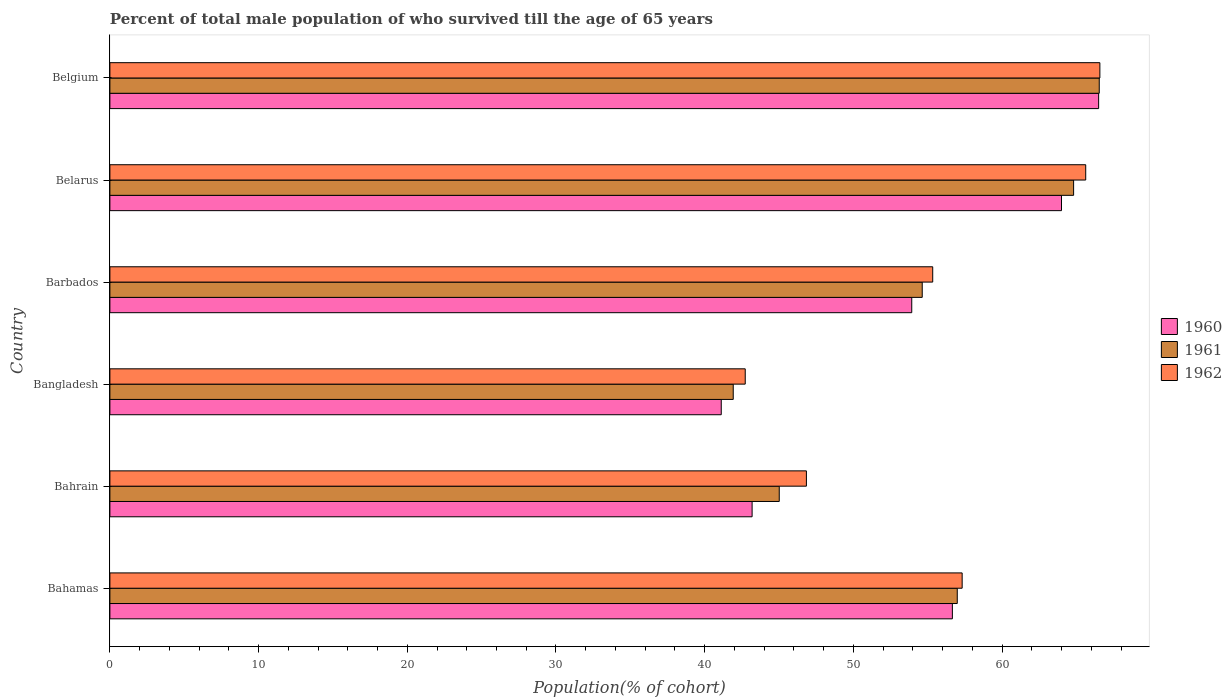How many groups of bars are there?
Your response must be concise. 6. Are the number of bars on each tick of the Y-axis equal?
Give a very brief answer. Yes. How many bars are there on the 1st tick from the top?
Offer a terse response. 3. How many bars are there on the 3rd tick from the bottom?
Your answer should be compact. 3. What is the label of the 5th group of bars from the top?
Offer a terse response. Bahrain. In how many cases, is the number of bars for a given country not equal to the number of legend labels?
Give a very brief answer. 0. What is the percentage of total male population who survived till the age of 65 years in 1960 in Belarus?
Your answer should be very brief. 64. Across all countries, what is the maximum percentage of total male population who survived till the age of 65 years in 1960?
Offer a very short reply. 66.5. Across all countries, what is the minimum percentage of total male population who survived till the age of 65 years in 1960?
Provide a succinct answer. 41.12. In which country was the percentage of total male population who survived till the age of 65 years in 1962 minimum?
Keep it short and to the point. Bangladesh. What is the total percentage of total male population who survived till the age of 65 years in 1962 in the graph?
Offer a very short reply. 334.43. What is the difference between the percentage of total male population who survived till the age of 65 years in 1960 in Barbados and that in Belarus?
Your response must be concise. -10.07. What is the difference between the percentage of total male population who survived till the age of 65 years in 1960 in Belarus and the percentage of total male population who survived till the age of 65 years in 1962 in Belgium?
Your response must be concise. -2.58. What is the average percentage of total male population who survived till the age of 65 years in 1960 per country?
Your answer should be very brief. 54.23. What is the difference between the percentage of total male population who survived till the age of 65 years in 1961 and percentage of total male population who survived till the age of 65 years in 1960 in Belgium?
Keep it short and to the point. 0.04. In how many countries, is the percentage of total male population who survived till the age of 65 years in 1960 greater than 50 %?
Offer a very short reply. 4. What is the ratio of the percentage of total male population who survived till the age of 65 years in 1960 in Bahrain to that in Bangladesh?
Provide a succinct answer. 1.05. What is the difference between the highest and the second highest percentage of total male population who survived till the age of 65 years in 1960?
Ensure brevity in your answer.  2.5. What is the difference between the highest and the lowest percentage of total male population who survived till the age of 65 years in 1960?
Provide a short and direct response. 25.38. In how many countries, is the percentage of total male population who survived till the age of 65 years in 1960 greater than the average percentage of total male population who survived till the age of 65 years in 1960 taken over all countries?
Provide a short and direct response. 3. Is the sum of the percentage of total male population who survived till the age of 65 years in 1962 in Bangladesh and Belarus greater than the maximum percentage of total male population who survived till the age of 65 years in 1960 across all countries?
Your answer should be very brief. Yes. What does the 3rd bar from the top in Bangladesh represents?
Keep it short and to the point. 1960. Is it the case that in every country, the sum of the percentage of total male population who survived till the age of 65 years in 1961 and percentage of total male population who survived till the age of 65 years in 1962 is greater than the percentage of total male population who survived till the age of 65 years in 1960?
Offer a terse response. Yes. Are all the bars in the graph horizontal?
Ensure brevity in your answer.  Yes. What is the difference between two consecutive major ticks on the X-axis?
Offer a terse response. 10. Are the values on the major ticks of X-axis written in scientific E-notation?
Ensure brevity in your answer.  No. Where does the legend appear in the graph?
Provide a short and direct response. Center right. What is the title of the graph?
Provide a short and direct response. Percent of total male population of who survived till the age of 65 years. What is the label or title of the X-axis?
Offer a terse response. Population(% of cohort). What is the label or title of the Y-axis?
Your answer should be very brief. Country. What is the Population(% of cohort) of 1960 in Bahamas?
Offer a very short reply. 56.66. What is the Population(% of cohort) in 1961 in Bahamas?
Offer a terse response. 56.99. What is the Population(% of cohort) in 1962 in Bahamas?
Ensure brevity in your answer.  57.32. What is the Population(% of cohort) of 1960 in Bahrain?
Ensure brevity in your answer.  43.19. What is the Population(% of cohort) in 1961 in Bahrain?
Your answer should be compact. 45.02. What is the Population(% of cohort) in 1962 in Bahrain?
Provide a succinct answer. 46.84. What is the Population(% of cohort) of 1960 in Bangladesh?
Your response must be concise. 41.12. What is the Population(% of cohort) of 1961 in Bangladesh?
Provide a short and direct response. 41.92. What is the Population(% of cohort) in 1962 in Bangladesh?
Provide a short and direct response. 42.73. What is the Population(% of cohort) of 1960 in Barbados?
Your answer should be very brief. 53.93. What is the Population(% of cohort) of 1961 in Barbados?
Offer a very short reply. 54.63. What is the Population(% of cohort) in 1962 in Barbados?
Offer a terse response. 55.34. What is the Population(% of cohort) in 1960 in Belarus?
Offer a terse response. 64. What is the Population(% of cohort) of 1961 in Belarus?
Make the answer very short. 64.81. What is the Population(% of cohort) in 1962 in Belarus?
Keep it short and to the point. 65.63. What is the Population(% of cohort) of 1960 in Belgium?
Your response must be concise. 66.5. What is the Population(% of cohort) in 1961 in Belgium?
Ensure brevity in your answer.  66.54. What is the Population(% of cohort) of 1962 in Belgium?
Ensure brevity in your answer.  66.58. Across all countries, what is the maximum Population(% of cohort) in 1960?
Your answer should be compact. 66.5. Across all countries, what is the maximum Population(% of cohort) of 1961?
Offer a terse response. 66.54. Across all countries, what is the maximum Population(% of cohort) of 1962?
Offer a terse response. 66.58. Across all countries, what is the minimum Population(% of cohort) of 1960?
Your answer should be compact. 41.12. Across all countries, what is the minimum Population(% of cohort) in 1961?
Your answer should be very brief. 41.92. Across all countries, what is the minimum Population(% of cohort) in 1962?
Provide a succinct answer. 42.73. What is the total Population(% of cohort) in 1960 in the graph?
Your answer should be compact. 325.39. What is the total Population(% of cohort) of 1961 in the graph?
Provide a short and direct response. 329.91. What is the total Population(% of cohort) of 1962 in the graph?
Your answer should be very brief. 334.43. What is the difference between the Population(% of cohort) of 1960 in Bahamas and that in Bahrain?
Ensure brevity in your answer.  13.47. What is the difference between the Population(% of cohort) of 1961 in Bahamas and that in Bahrain?
Ensure brevity in your answer.  11.97. What is the difference between the Population(% of cohort) in 1962 in Bahamas and that in Bahrain?
Ensure brevity in your answer.  10.47. What is the difference between the Population(% of cohort) of 1960 in Bahamas and that in Bangladesh?
Your answer should be compact. 15.54. What is the difference between the Population(% of cohort) of 1961 in Bahamas and that in Bangladesh?
Your response must be concise. 15.07. What is the difference between the Population(% of cohort) in 1962 in Bahamas and that in Bangladesh?
Give a very brief answer. 14.59. What is the difference between the Population(% of cohort) of 1960 in Bahamas and that in Barbados?
Offer a terse response. 2.73. What is the difference between the Population(% of cohort) in 1961 in Bahamas and that in Barbados?
Ensure brevity in your answer.  2.36. What is the difference between the Population(% of cohort) in 1962 in Bahamas and that in Barbados?
Make the answer very short. 1.98. What is the difference between the Population(% of cohort) of 1960 in Bahamas and that in Belarus?
Your answer should be compact. -7.34. What is the difference between the Population(% of cohort) of 1961 in Bahamas and that in Belarus?
Your response must be concise. -7.82. What is the difference between the Population(% of cohort) in 1962 in Bahamas and that in Belarus?
Your response must be concise. -8.31. What is the difference between the Population(% of cohort) of 1960 in Bahamas and that in Belgium?
Provide a succinct answer. -9.84. What is the difference between the Population(% of cohort) of 1961 in Bahamas and that in Belgium?
Provide a succinct answer. -9.55. What is the difference between the Population(% of cohort) in 1962 in Bahamas and that in Belgium?
Your response must be concise. -9.26. What is the difference between the Population(% of cohort) in 1960 in Bahrain and that in Bangladesh?
Offer a terse response. 2.08. What is the difference between the Population(% of cohort) in 1961 in Bahrain and that in Bangladesh?
Provide a succinct answer. 3.09. What is the difference between the Population(% of cohort) of 1962 in Bahrain and that in Bangladesh?
Provide a succinct answer. 4.11. What is the difference between the Population(% of cohort) in 1960 in Bahrain and that in Barbados?
Make the answer very short. -10.74. What is the difference between the Population(% of cohort) of 1961 in Bahrain and that in Barbados?
Your answer should be very brief. -9.62. What is the difference between the Population(% of cohort) in 1962 in Bahrain and that in Barbados?
Offer a very short reply. -8.5. What is the difference between the Population(% of cohort) of 1960 in Bahrain and that in Belarus?
Your response must be concise. -20.81. What is the difference between the Population(% of cohort) in 1961 in Bahrain and that in Belarus?
Your answer should be very brief. -19.8. What is the difference between the Population(% of cohort) of 1962 in Bahrain and that in Belarus?
Offer a terse response. -18.78. What is the difference between the Population(% of cohort) in 1960 in Bahrain and that in Belgium?
Give a very brief answer. -23.31. What is the difference between the Population(% of cohort) of 1961 in Bahrain and that in Belgium?
Offer a terse response. -21.52. What is the difference between the Population(% of cohort) in 1962 in Bahrain and that in Belgium?
Offer a very short reply. -19.74. What is the difference between the Population(% of cohort) in 1960 in Bangladesh and that in Barbados?
Offer a very short reply. -12.81. What is the difference between the Population(% of cohort) in 1961 in Bangladesh and that in Barbados?
Provide a succinct answer. -12.71. What is the difference between the Population(% of cohort) in 1962 in Bangladesh and that in Barbados?
Offer a very short reply. -12.61. What is the difference between the Population(% of cohort) in 1960 in Bangladesh and that in Belarus?
Your answer should be compact. -22.88. What is the difference between the Population(% of cohort) of 1961 in Bangladesh and that in Belarus?
Your answer should be compact. -22.89. What is the difference between the Population(% of cohort) in 1962 in Bangladesh and that in Belarus?
Make the answer very short. -22.9. What is the difference between the Population(% of cohort) of 1960 in Bangladesh and that in Belgium?
Give a very brief answer. -25.38. What is the difference between the Population(% of cohort) of 1961 in Bangladesh and that in Belgium?
Your answer should be very brief. -24.62. What is the difference between the Population(% of cohort) in 1962 in Bangladesh and that in Belgium?
Provide a succinct answer. -23.85. What is the difference between the Population(% of cohort) in 1960 in Barbados and that in Belarus?
Provide a short and direct response. -10.07. What is the difference between the Population(% of cohort) of 1961 in Barbados and that in Belarus?
Give a very brief answer. -10.18. What is the difference between the Population(% of cohort) of 1962 in Barbados and that in Belarus?
Provide a succinct answer. -10.29. What is the difference between the Population(% of cohort) of 1960 in Barbados and that in Belgium?
Make the answer very short. -12.57. What is the difference between the Population(% of cohort) in 1961 in Barbados and that in Belgium?
Ensure brevity in your answer.  -11.9. What is the difference between the Population(% of cohort) in 1962 in Barbados and that in Belgium?
Provide a short and direct response. -11.24. What is the difference between the Population(% of cohort) in 1960 in Belarus and that in Belgium?
Give a very brief answer. -2.5. What is the difference between the Population(% of cohort) of 1961 in Belarus and that in Belgium?
Provide a succinct answer. -1.72. What is the difference between the Population(% of cohort) of 1962 in Belarus and that in Belgium?
Your answer should be very brief. -0.95. What is the difference between the Population(% of cohort) in 1960 in Bahamas and the Population(% of cohort) in 1961 in Bahrain?
Provide a succinct answer. 11.64. What is the difference between the Population(% of cohort) in 1960 in Bahamas and the Population(% of cohort) in 1962 in Bahrain?
Make the answer very short. 9.82. What is the difference between the Population(% of cohort) in 1961 in Bahamas and the Population(% of cohort) in 1962 in Bahrain?
Provide a succinct answer. 10.15. What is the difference between the Population(% of cohort) in 1960 in Bahamas and the Population(% of cohort) in 1961 in Bangladesh?
Offer a terse response. 14.74. What is the difference between the Population(% of cohort) in 1960 in Bahamas and the Population(% of cohort) in 1962 in Bangladesh?
Provide a short and direct response. 13.93. What is the difference between the Population(% of cohort) of 1961 in Bahamas and the Population(% of cohort) of 1962 in Bangladesh?
Make the answer very short. 14.26. What is the difference between the Population(% of cohort) in 1960 in Bahamas and the Population(% of cohort) in 1961 in Barbados?
Offer a terse response. 2.03. What is the difference between the Population(% of cohort) in 1960 in Bahamas and the Population(% of cohort) in 1962 in Barbados?
Offer a very short reply. 1.32. What is the difference between the Population(% of cohort) of 1961 in Bahamas and the Population(% of cohort) of 1962 in Barbados?
Ensure brevity in your answer.  1.65. What is the difference between the Population(% of cohort) in 1960 in Bahamas and the Population(% of cohort) in 1961 in Belarus?
Make the answer very short. -8.15. What is the difference between the Population(% of cohort) in 1960 in Bahamas and the Population(% of cohort) in 1962 in Belarus?
Your response must be concise. -8.97. What is the difference between the Population(% of cohort) of 1961 in Bahamas and the Population(% of cohort) of 1962 in Belarus?
Give a very brief answer. -8.64. What is the difference between the Population(% of cohort) in 1960 in Bahamas and the Population(% of cohort) in 1961 in Belgium?
Your response must be concise. -9.88. What is the difference between the Population(% of cohort) in 1960 in Bahamas and the Population(% of cohort) in 1962 in Belgium?
Ensure brevity in your answer.  -9.92. What is the difference between the Population(% of cohort) in 1961 in Bahamas and the Population(% of cohort) in 1962 in Belgium?
Make the answer very short. -9.59. What is the difference between the Population(% of cohort) in 1960 in Bahrain and the Population(% of cohort) in 1961 in Bangladesh?
Your answer should be compact. 1.27. What is the difference between the Population(% of cohort) in 1960 in Bahrain and the Population(% of cohort) in 1962 in Bangladesh?
Give a very brief answer. 0.46. What is the difference between the Population(% of cohort) of 1961 in Bahrain and the Population(% of cohort) of 1962 in Bangladesh?
Your answer should be very brief. 2.29. What is the difference between the Population(% of cohort) of 1960 in Bahrain and the Population(% of cohort) of 1961 in Barbados?
Your answer should be very brief. -11.44. What is the difference between the Population(% of cohort) in 1960 in Bahrain and the Population(% of cohort) in 1962 in Barbados?
Provide a succinct answer. -12.15. What is the difference between the Population(% of cohort) in 1961 in Bahrain and the Population(% of cohort) in 1962 in Barbados?
Offer a terse response. -10.32. What is the difference between the Population(% of cohort) in 1960 in Bahrain and the Population(% of cohort) in 1961 in Belarus?
Your response must be concise. -21.62. What is the difference between the Population(% of cohort) of 1960 in Bahrain and the Population(% of cohort) of 1962 in Belarus?
Provide a short and direct response. -22.44. What is the difference between the Population(% of cohort) in 1961 in Bahrain and the Population(% of cohort) in 1962 in Belarus?
Provide a short and direct response. -20.61. What is the difference between the Population(% of cohort) in 1960 in Bahrain and the Population(% of cohort) in 1961 in Belgium?
Keep it short and to the point. -23.35. What is the difference between the Population(% of cohort) of 1960 in Bahrain and the Population(% of cohort) of 1962 in Belgium?
Your response must be concise. -23.39. What is the difference between the Population(% of cohort) of 1961 in Bahrain and the Population(% of cohort) of 1962 in Belgium?
Ensure brevity in your answer.  -21.56. What is the difference between the Population(% of cohort) of 1960 in Bangladesh and the Population(% of cohort) of 1961 in Barbados?
Make the answer very short. -13.52. What is the difference between the Population(% of cohort) of 1960 in Bangladesh and the Population(% of cohort) of 1962 in Barbados?
Your response must be concise. -14.22. What is the difference between the Population(% of cohort) of 1961 in Bangladesh and the Population(% of cohort) of 1962 in Barbados?
Make the answer very short. -13.42. What is the difference between the Population(% of cohort) of 1960 in Bangladesh and the Population(% of cohort) of 1961 in Belarus?
Provide a succinct answer. -23.7. What is the difference between the Population(% of cohort) of 1960 in Bangladesh and the Population(% of cohort) of 1962 in Belarus?
Give a very brief answer. -24.51. What is the difference between the Population(% of cohort) of 1961 in Bangladesh and the Population(% of cohort) of 1962 in Belarus?
Provide a succinct answer. -23.71. What is the difference between the Population(% of cohort) in 1960 in Bangladesh and the Population(% of cohort) in 1961 in Belgium?
Keep it short and to the point. -25.42. What is the difference between the Population(% of cohort) of 1960 in Bangladesh and the Population(% of cohort) of 1962 in Belgium?
Keep it short and to the point. -25.46. What is the difference between the Population(% of cohort) in 1961 in Bangladesh and the Population(% of cohort) in 1962 in Belgium?
Your response must be concise. -24.66. What is the difference between the Population(% of cohort) in 1960 in Barbados and the Population(% of cohort) in 1961 in Belarus?
Keep it short and to the point. -10.89. What is the difference between the Population(% of cohort) in 1960 in Barbados and the Population(% of cohort) in 1962 in Belarus?
Your answer should be very brief. -11.7. What is the difference between the Population(% of cohort) in 1961 in Barbados and the Population(% of cohort) in 1962 in Belarus?
Keep it short and to the point. -10.99. What is the difference between the Population(% of cohort) of 1960 in Barbados and the Population(% of cohort) of 1961 in Belgium?
Offer a terse response. -12.61. What is the difference between the Population(% of cohort) of 1960 in Barbados and the Population(% of cohort) of 1962 in Belgium?
Your response must be concise. -12.65. What is the difference between the Population(% of cohort) of 1961 in Barbados and the Population(% of cohort) of 1962 in Belgium?
Your answer should be compact. -11.95. What is the difference between the Population(% of cohort) in 1960 in Belarus and the Population(% of cohort) in 1961 in Belgium?
Your answer should be very brief. -2.54. What is the difference between the Population(% of cohort) of 1960 in Belarus and the Population(% of cohort) of 1962 in Belgium?
Provide a succinct answer. -2.58. What is the difference between the Population(% of cohort) in 1961 in Belarus and the Population(% of cohort) in 1962 in Belgium?
Provide a succinct answer. -1.77. What is the average Population(% of cohort) of 1960 per country?
Provide a succinct answer. 54.23. What is the average Population(% of cohort) in 1961 per country?
Your response must be concise. 54.99. What is the average Population(% of cohort) of 1962 per country?
Keep it short and to the point. 55.74. What is the difference between the Population(% of cohort) in 1960 and Population(% of cohort) in 1961 in Bahamas?
Provide a short and direct response. -0.33. What is the difference between the Population(% of cohort) of 1960 and Population(% of cohort) of 1962 in Bahamas?
Your answer should be compact. -0.66. What is the difference between the Population(% of cohort) in 1961 and Population(% of cohort) in 1962 in Bahamas?
Provide a short and direct response. -0.33. What is the difference between the Population(% of cohort) of 1960 and Population(% of cohort) of 1961 in Bahrain?
Make the answer very short. -1.83. What is the difference between the Population(% of cohort) in 1960 and Population(% of cohort) in 1962 in Bahrain?
Provide a succinct answer. -3.65. What is the difference between the Population(% of cohort) of 1961 and Population(% of cohort) of 1962 in Bahrain?
Offer a very short reply. -1.83. What is the difference between the Population(% of cohort) of 1960 and Population(% of cohort) of 1961 in Bangladesh?
Give a very brief answer. -0.81. What is the difference between the Population(% of cohort) of 1960 and Population(% of cohort) of 1962 in Bangladesh?
Ensure brevity in your answer.  -1.61. What is the difference between the Population(% of cohort) of 1961 and Population(% of cohort) of 1962 in Bangladesh?
Ensure brevity in your answer.  -0.81. What is the difference between the Population(% of cohort) in 1960 and Population(% of cohort) in 1961 in Barbados?
Ensure brevity in your answer.  -0.71. What is the difference between the Population(% of cohort) of 1960 and Population(% of cohort) of 1962 in Barbados?
Keep it short and to the point. -1.41. What is the difference between the Population(% of cohort) of 1961 and Population(% of cohort) of 1962 in Barbados?
Offer a terse response. -0.71. What is the difference between the Population(% of cohort) of 1960 and Population(% of cohort) of 1961 in Belarus?
Offer a very short reply. -0.81. What is the difference between the Population(% of cohort) of 1960 and Population(% of cohort) of 1962 in Belarus?
Your answer should be very brief. -1.63. What is the difference between the Population(% of cohort) of 1961 and Population(% of cohort) of 1962 in Belarus?
Offer a very short reply. -0.81. What is the difference between the Population(% of cohort) in 1960 and Population(% of cohort) in 1961 in Belgium?
Offer a very short reply. -0.04. What is the difference between the Population(% of cohort) in 1960 and Population(% of cohort) in 1962 in Belgium?
Provide a succinct answer. -0.08. What is the difference between the Population(% of cohort) of 1961 and Population(% of cohort) of 1962 in Belgium?
Offer a terse response. -0.04. What is the ratio of the Population(% of cohort) in 1960 in Bahamas to that in Bahrain?
Your answer should be very brief. 1.31. What is the ratio of the Population(% of cohort) of 1961 in Bahamas to that in Bahrain?
Offer a terse response. 1.27. What is the ratio of the Population(% of cohort) in 1962 in Bahamas to that in Bahrain?
Provide a succinct answer. 1.22. What is the ratio of the Population(% of cohort) of 1960 in Bahamas to that in Bangladesh?
Provide a succinct answer. 1.38. What is the ratio of the Population(% of cohort) of 1961 in Bahamas to that in Bangladesh?
Your response must be concise. 1.36. What is the ratio of the Population(% of cohort) in 1962 in Bahamas to that in Bangladesh?
Keep it short and to the point. 1.34. What is the ratio of the Population(% of cohort) of 1960 in Bahamas to that in Barbados?
Keep it short and to the point. 1.05. What is the ratio of the Population(% of cohort) of 1961 in Bahamas to that in Barbados?
Make the answer very short. 1.04. What is the ratio of the Population(% of cohort) of 1962 in Bahamas to that in Barbados?
Offer a very short reply. 1.04. What is the ratio of the Population(% of cohort) of 1960 in Bahamas to that in Belarus?
Provide a succinct answer. 0.89. What is the ratio of the Population(% of cohort) of 1961 in Bahamas to that in Belarus?
Your answer should be very brief. 0.88. What is the ratio of the Population(% of cohort) in 1962 in Bahamas to that in Belarus?
Provide a succinct answer. 0.87. What is the ratio of the Population(% of cohort) in 1960 in Bahamas to that in Belgium?
Give a very brief answer. 0.85. What is the ratio of the Population(% of cohort) in 1961 in Bahamas to that in Belgium?
Keep it short and to the point. 0.86. What is the ratio of the Population(% of cohort) of 1962 in Bahamas to that in Belgium?
Make the answer very short. 0.86. What is the ratio of the Population(% of cohort) of 1960 in Bahrain to that in Bangladesh?
Give a very brief answer. 1.05. What is the ratio of the Population(% of cohort) in 1961 in Bahrain to that in Bangladesh?
Provide a succinct answer. 1.07. What is the ratio of the Population(% of cohort) of 1962 in Bahrain to that in Bangladesh?
Provide a succinct answer. 1.1. What is the ratio of the Population(% of cohort) in 1960 in Bahrain to that in Barbados?
Your answer should be very brief. 0.8. What is the ratio of the Population(% of cohort) in 1961 in Bahrain to that in Barbados?
Provide a succinct answer. 0.82. What is the ratio of the Population(% of cohort) of 1962 in Bahrain to that in Barbados?
Ensure brevity in your answer.  0.85. What is the ratio of the Population(% of cohort) of 1960 in Bahrain to that in Belarus?
Provide a succinct answer. 0.67. What is the ratio of the Population(% of cohort) in 1961 in Bahrain to that in Belarus?
Make the answer very short. 0.69. What is the ratio of the Population(% of cohort) in 1962 in Bahrain to that in Belarus?
Your answer should be compact. 0.71. What is the ratio of the Population(% of cohort) of 1960 in Bahrain to that in Belgium?
Your response must be concise. 0.65. What is the ratio of the Population(% of cohort) of 1961 in Bahrain to that in Belgium?
Offer a terse response. 0.68. What is the ratio of the Population(% of cohort) of 1962 in Bahrain to that in Belgium?
Ensure brevity in your answer.  0.7. What is the ratio of the Population(% of cohort) in 1960 in Bangladesh to that in Barbados?
Your answer should be compact. 0.76. What is the ratio of the Population(% of cohort) in 1961 in Bangladesh to that in Barbados?
Provide a succinct answer. 0.77. What is the ratio of the Population(% of cohort) of 1962 in Bangladesh to that in Barbados?
Your answer should be very brief. 0.77. What is the ratio of the Population(% of cohort) in 1960 in Bangladesh to that in Belarus?
Ensure brevity in your answer.  0.64. What is the ratio of the Population(% of cohort) of 1961 in Bangladesh to that in Belarus?
Your answer should be very brief. 0.65. What is the ratio of the Population(% of cohort) in 1962 in Bangladesh to that in Belarus?
Offer a very short reply. 0.65. What is the ratio of the Population(% of cohort) of 1960 in Bangladesh to that in Belgium?
Give a very brief answer. 0.62. What is the ratio of the Population(% of cohort) of 1961 in Bangladesh to that in Belgium?
Ensure brevity in your answer.  0.63. What is the ratio of the Population(% of cohort) in 1962 in Bangladesh to that in Belgium?
Provide a succinct answer. 0.64. What is the ratio of the Population(% of cohort) of 1960 in Barbados to that in Belarus?
Your answer should be very brief. 0.84. What is the ratio of the Population(% of cohort) of 1961 in Barbados to that in Belarus?
Your response must be concise. 0.84. What is the ratio of the Population(% of cohort) in 1962 in Barbados to that in Belarus?
Make the answer very short. 0.84. What is the ratio of the Population(% of cohort) of 1960 in Barbados to that in Belgium?
Offer a terse response. 0.81. What is the ratio of the Population(% of cohort) in 1961 in Barbados to that in Belgium?
Ensure brevity in your answer.  0.82. What is the ratio of the Population(% of cohort) of 1962 in Barbados to that in Belgium?
Ensure brevity in your answer.  0.83. What is the ratio of the Population(% of cohort) in 1960 in Belarus to that in Belgium?
Ensure brevity in your answer.  0.96. What is the ratio of the Population(% of cohort) in 1961 in Belarus to that in Belgium?
Provide a succinct answer. 0.97. What is the ratio of the Population(% of cohort) of 1962 in Belarus to that in Belgium?
Offer a very short reply. 0.99. What is the difference between the highest and the second highest Population(% of cohort) in 1960?
Your answer should be compact. 2.5. What is the difference between the highest and the second highest Population(% of cohort) of 1961?
Ensure brevity in your answer.  1.72. What is the difference between the highest and the second highest Population(% of cohort) of 1962?
Give a very brief answer. 0.95. What is the difference between the highest and the lowest Population(% of cohort) of 1960?
Your answer should be very brief. 25.38. What is the difference between the highest and the lowest Population(% of cohort) in 1961?
Your response must be concise. 24.62. What is the difference between the highest and the lowest Population(% of cohort) of 1962?
Your response must be concise. 23.85. 